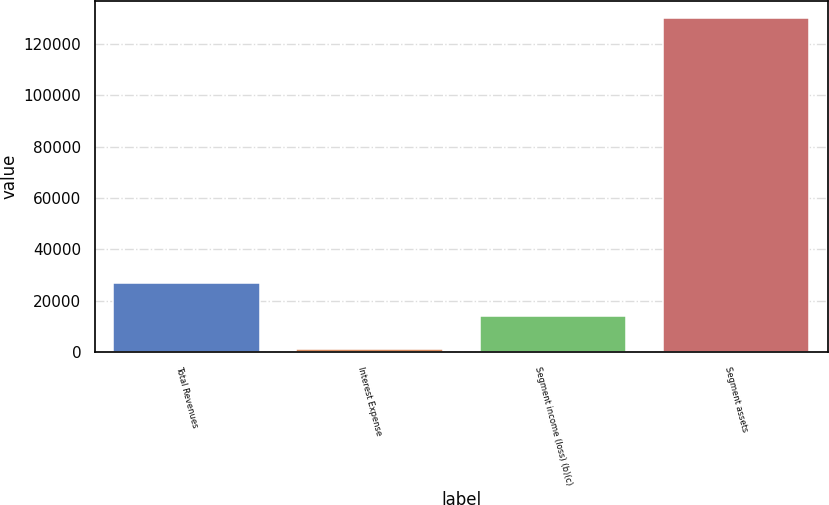Convert chart. <chart><loc_0><loc_0><loc_500><loc_500><bar_chart><fcel>Total Revenues<fcel>Interest Expense<fcel>Segment income (loss) (b)(c)<fcel>Segment assets<nl><fcel>27014<fcel>1235<fcel>14124.5<fcel>130130<nl></chart> 